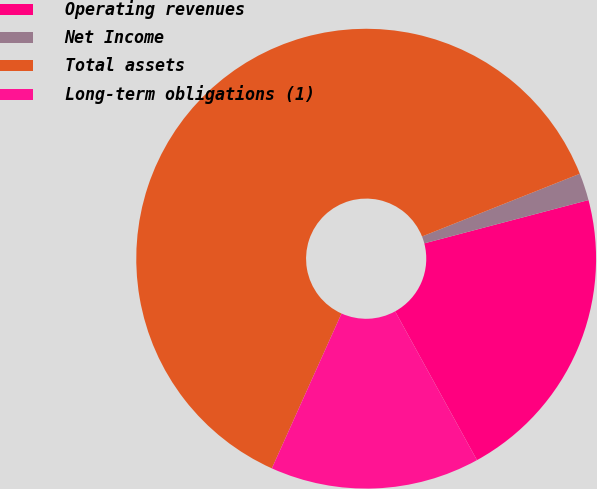Convert chart. <chart><loc_0><loc_0><loc_500><loc_500><pie_chart><fcel>Operating revenues<fcel>Net Income<fcel>Total assets<fcel>Long-term obligations (1)<nl><fcel>21.1%<fcel>1.92%<fcel>62.25%<fcel>14.73%<nl></chart> 